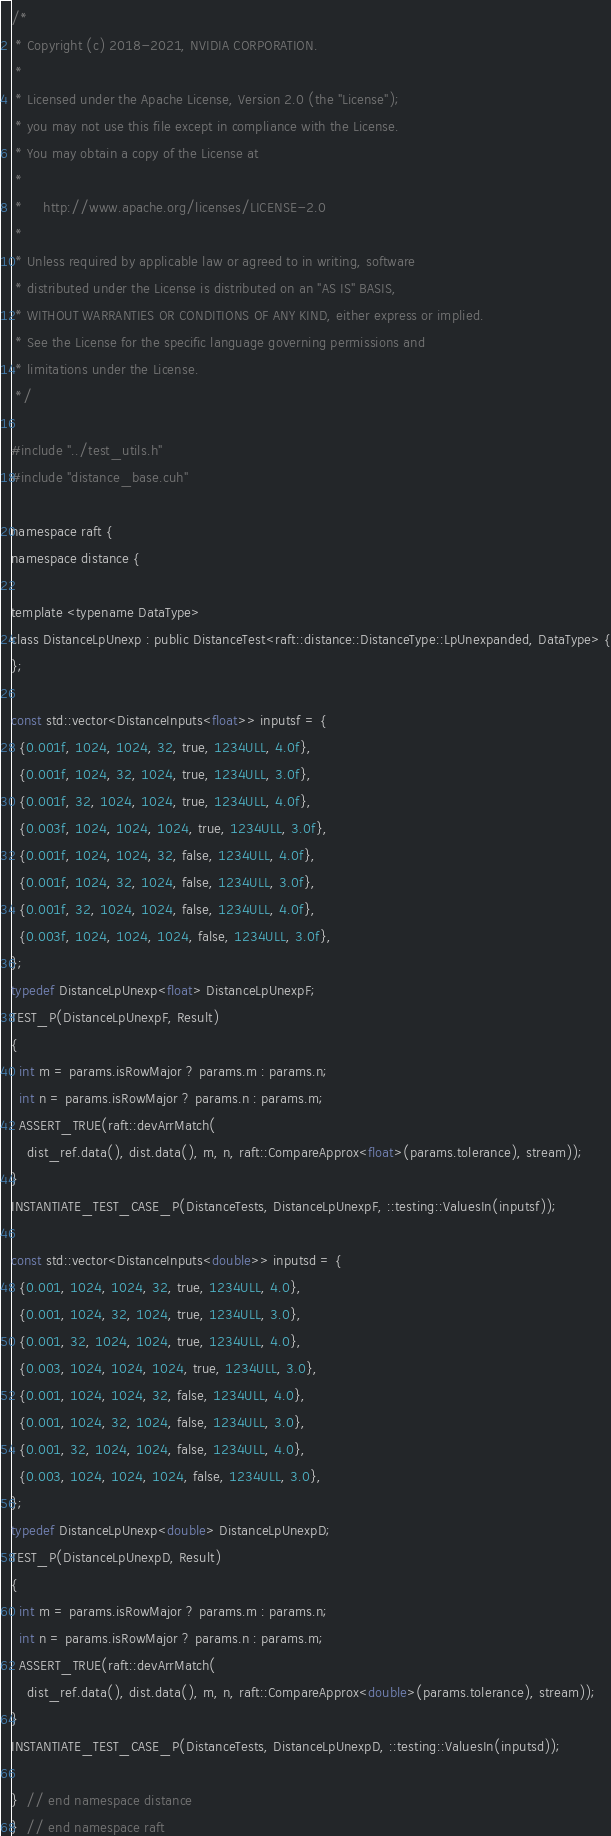Convert code to text. <code><loc_0><loc_0><loc_500><loc_500><_Cuda_>/*
 * Copyright (c) 2018-2021, NVIDIA CORPORATION.
 *
 * Licensed under the Apache License, Version 2.0 (the "License");
 * you may not use this file except in compliance with the License.
 * You may obtain a copy of the License at
 *
 *     http://www.apache.org/licenses/LICENSE-2.0
 *
 * Unless required by applicable law or agreed to in writing, software
 * distributed under the License is distributed on an "AS IS" BASIS,
 * WITHOUT WARRANTIES OR CONDITIONS OF ANY KIND, either express or implied.
 * See the License for the specific language governing permissions and
 * limitations under the License.
 */

#include "../test_utils.h"
#include "distance_base.cuh"

namespace raft {
namespace distance {

template <typename DataType>
class DistanceLpUnexp : public DistanceTest<raft::distance::DistanceType::LpUnexpanded, DataType> {
};

const std::vector<DistanceInputs<float>> inputsf = {
  {0.001f, 1024, 1024, 32, true, 1234ULL, 4.0f},
  {0.001f, 1024, 32, 1024, true, 1234ULL, 3.0f},
  {0.001f, 32, 1024, 1024, true, 1234ULL, 4.0f},
  {0.003f, 1024, 1024, 1024, true, 1234ULL, 3.0f},
  {0.001f, 1024, 1024, 32, false, 1234ULL, 4.0f},
  {0.001f, 1024, 32, 1024, false, 1234ULL, 3.0f},
  {0.001f, 32, 1024, 1024, false, 1234ULL, 4.0f},
  {0.003f, 1024, 1024, 1024, false, 1234ULL, 3.0f},
};
typedef DistanceLpUnexp<float> DistanceLpUnexpF;
TEST_P(DistanceLpUnexpF, Result)
{
  int m = params.isRowMajor ? params.m : params.n;
  int n = params.isRowMajor ? params.n : params.m;
  ASSERT_TRUE(raft::devArrMatch(
    dist_ref.data(), dist.data(), m, n, raft::CompareApprox<float>(params.tolerance), stream));
}
INSTANTIATE_TEST_CASE_P(DistanceTests, DistanceLpUnexpF, ::testing::ValuesIn(inputsf));

const std::vector<DistanceInputs<double>> inputsd = {
  {0.001, 1024, 1024, 32, true, 1234ULL, 4.0},
  {0.001, 1024, 32, 1024, true, 1234ULL, 3.0},
  {0.001, 32, 1024, 1024, true, 1234ULL, 4.0},
  {0.003, 1024, 1024, 1024, true, 1234ULL, 3.0},
  {0.001, 1024, 1024, 32, false, 1234ULL, 4.0},
  {0.001, 1024, 32, 1024, false, 1234ULL, 3.0},
  {0.001, 32, 1024, 1024, false, 1234ULL, 4.0},
  {0.003, 1024, 1024, 1024, false, 1234ULL, 3.0},
};
typedef DistanceLpUnexp<double> DistanceLpUnexpD;
TEST_P(DistanceLpUnexpD, Result)
{
  int m = params.isRowMajor ? params.m : params.n;
  int n = params.isRowMajor ? params.n : params.m;
  ASSERT_TRUE(raft::devArrMatch(
    dist_ref.data(), dist.data(), m, n, raft::CompareApprox<double>(params.tolerance), stream));
}
INSTANTIATE_TEST_CASE_P(DistanceTests, DistanceLpUnexpD, ::testing::ValuesIn(inputsd));

}  // end namespace distance
}  // end namespace raft
</code> 